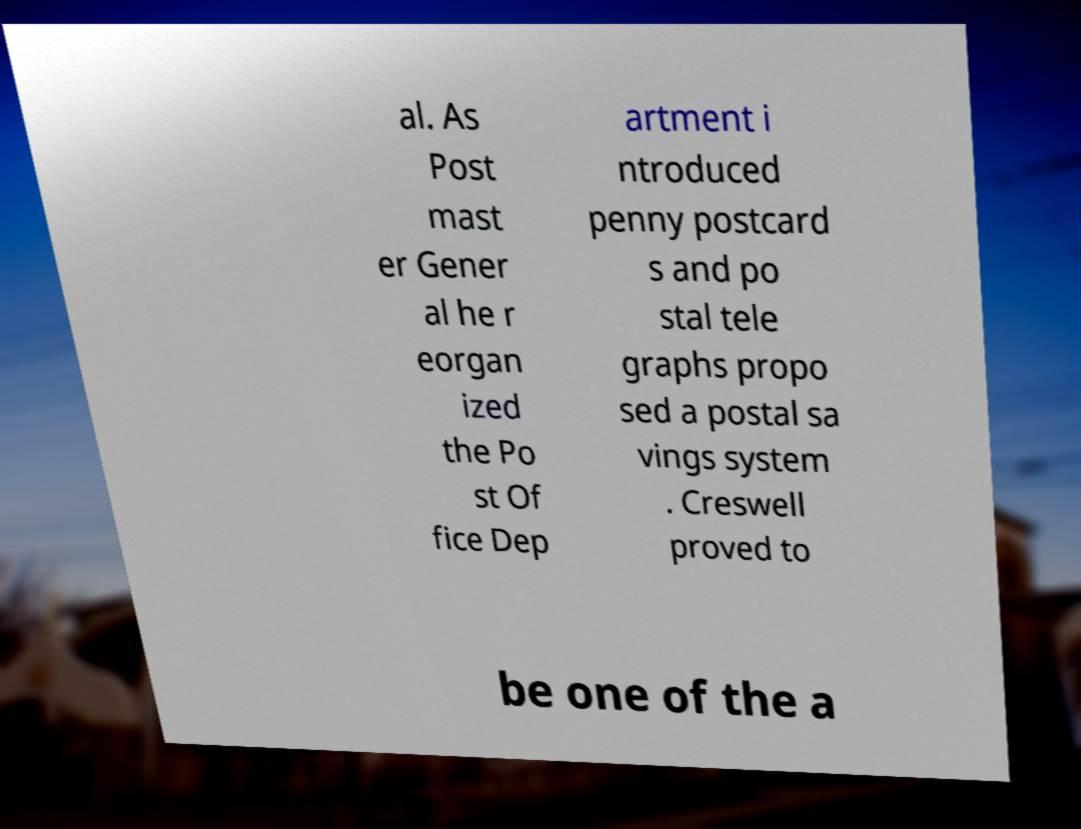There's text embedded in this image that I need extracted. Can you transcribe it verbatim? al. As Post mast er Gener al he r eorgan ized the Po st Of fice Dep artment i ntroduced penny postcard s and po stal tele graphs propo sed a postal sa vings system . Creswell proved to be one of the a 